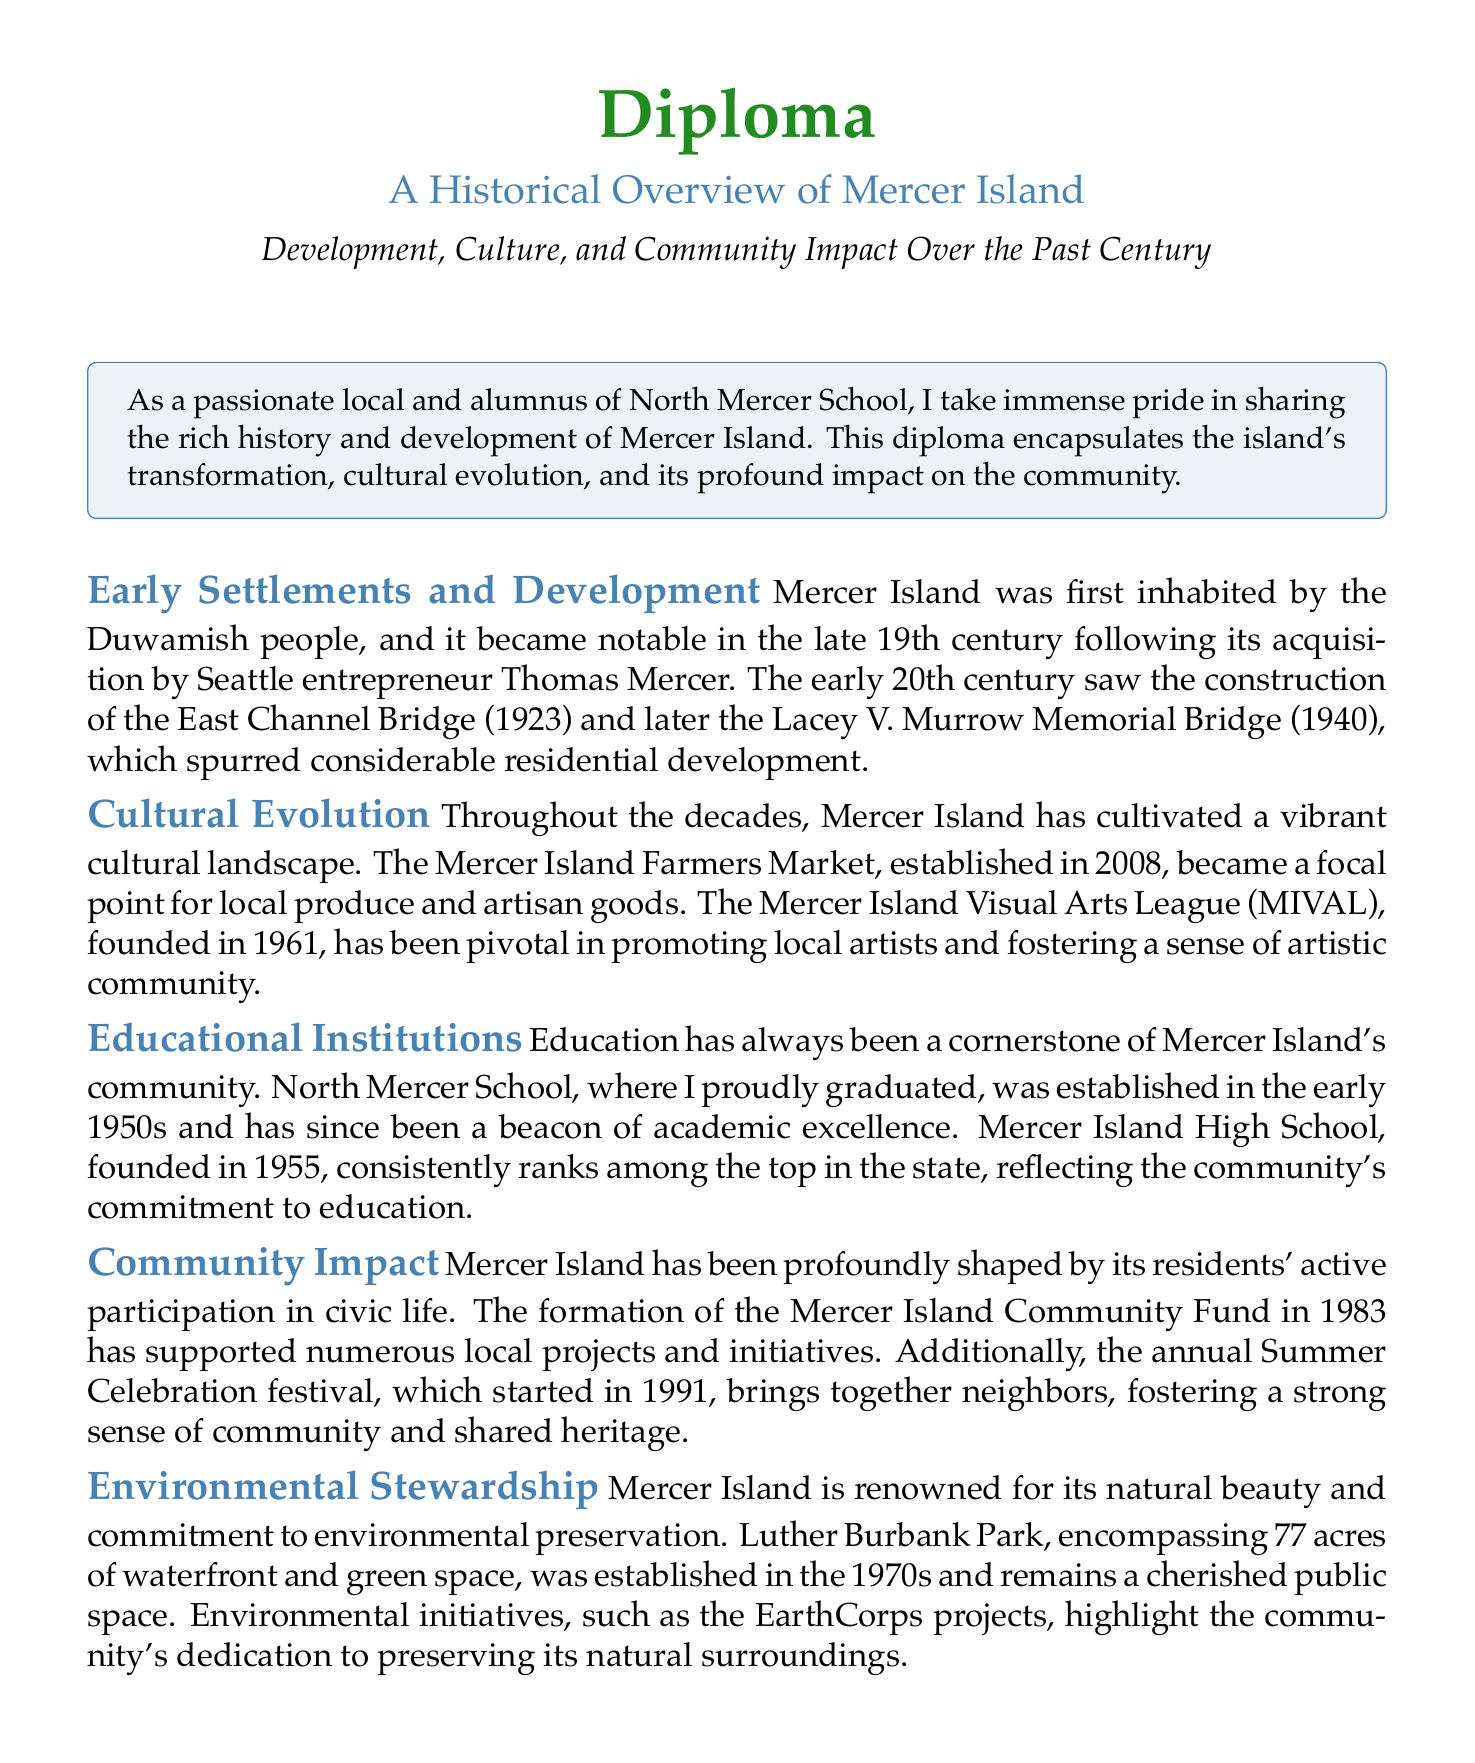What year was the East Channel Bridge constructed? The document states that the East Channel Bridge was constructed in 1923.
Answer: 1923 Who was the Seattle entrepreneur that acquired Mercer Island? The entrepreneur who acquired Mercer Island was Thomas Mercer.
Answer: Thomas Mercer In what year was the Mercer Island Farmers Market established? According to the document, the Mercer Island Farmers Market was established in 2008.
Answer: 2008 What is the name of the community fund established in 1983? The document mentions the Mercer Island Community Fund, established in 1983.
Answer: Mercer Island Community Fund How many acres is Luther Burbank Park? The document specifies that Luther Burbank Park encompasses 77 acres.
Answer: 77 acres What year was North Mercer School established? The document states that North Mercer School was established in the early 1950s.
Answer: early 1950s Which bridge was constructed in 1940? The Lacey V. Murrow Memorial Bridge was constructed in 1940, as mentioned in the document.
Answer: Lacey V. Murrow Memorial Bridge What organization promotes local artists in Mercer Island? The Mercer Island Visual Arts League (MIVAL) promotes local artists.
Answer: Mercer Island Visual Arts League (MIVAL) What festival started in 1991 to foster community? The document states that the annual Summer Celebration festival started in 1991.
Answer: Summer Celebration 